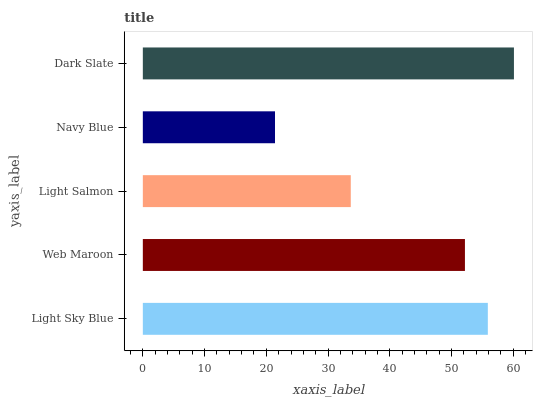Is Navy Blue the minimum?
Answer yes or no. Yes. Is Dark Slate the maximum?
Answer yes or no. Yes. Is Web Maroon the minimum?
Answer yes or no. No. Is Web Maroon the maximum?
Answer yes or no. No. Is Light Sky Blue greater than Web Maroon?
Answer yes or no. Yes. Is Web Maroon less than Light Sky Blue?
Answer yes or no. Yes. Is Web Maroon greater than Light Sky Blue?
Answer yes or no. No. Is Light Sky Blue less than Web Maroon?
Answer yes or no. No. Is Web Maroon the high median?
Answer yes or no. Yes. Is Web Maroon the low median?
Answer yes or no. Yes. Is Light Sky Blue the high median?
Answer yes or no. No. Is Light Salmon the low median?
Answer yes or no. No. 